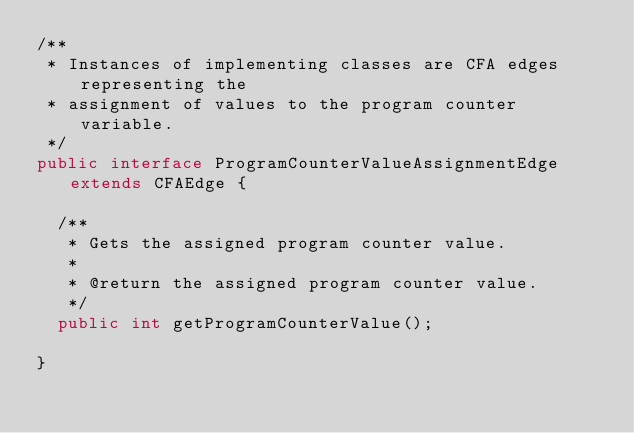<code> <loc_0><loc_0><loc_500><loc_500><_Java_>/**
 * Instances of implementing classes are CFA edges representing the
 * assignment of values to the program counter variable.
 */
public interface ProgramCounterValueAssignmentEdge extends CFAEdge {

  /**
   * Gets the assigned program counter value.
   *
   * @return the assigned program counter value.
   */
  public int getProgramCounterValue();

}</code> 